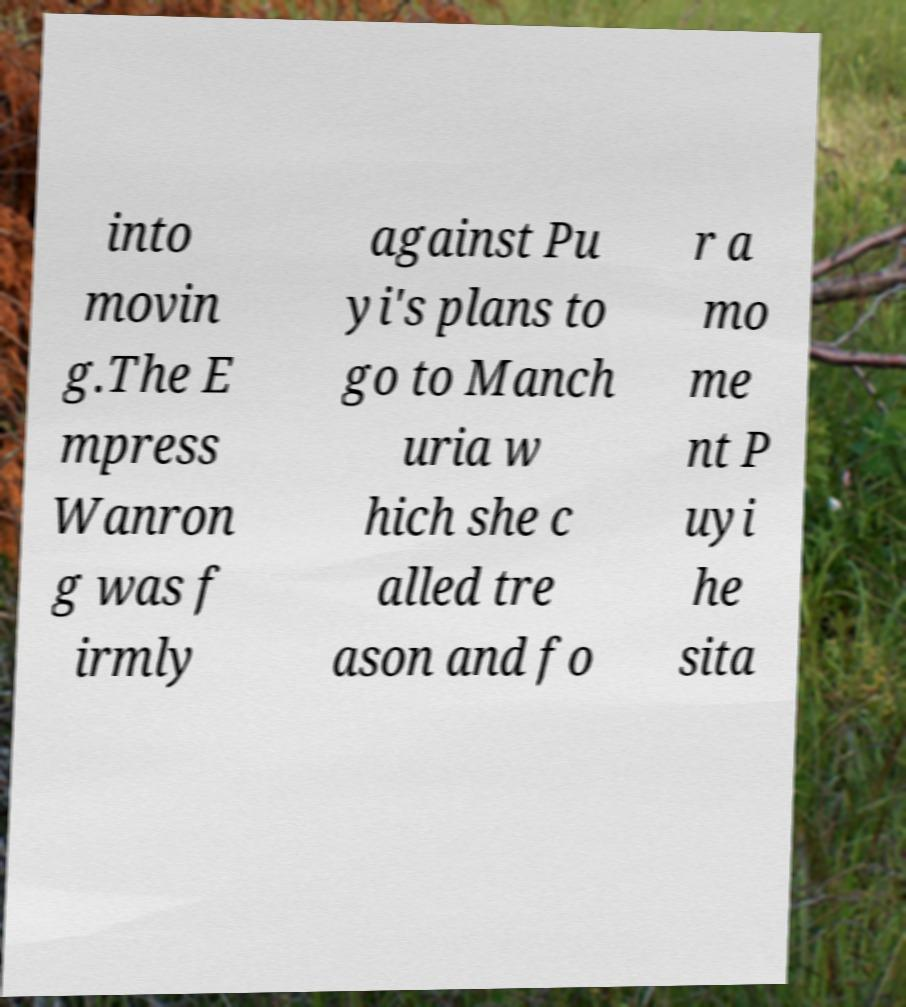Please read and relay the text visible in this image. What does it say? into movin g.The E mpress Wanron g was f irmly against Pu yi's plans to go to Manch uria w hich she c alled tre ason and fo r a mo me nt P uyi he sita 